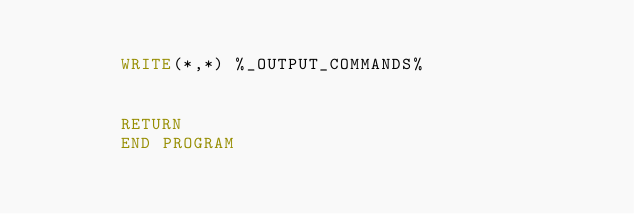<code> <loc_0><loc_0><loc_500><loc_500><_FORTRAN_>
        WRITE(*,*) %_OUTPUT_COMMANDS%


        RETURN
        END PROGRAM
</code> 